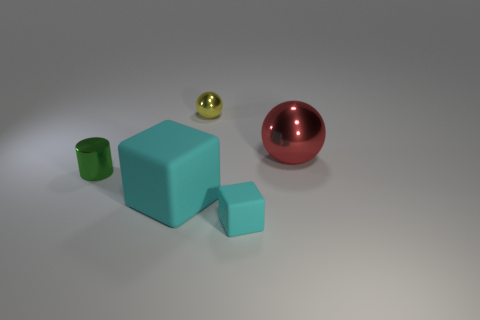How many cyan blocks must be subtracted to get 1 cyan blocks? 1 Add 4 tiny cyan things. How many objects exist? 9 Subtract all cubes. How many objects are left? 3 Add 4 large cyan matte blocks. How many large cyan matte blocks are left? 5 Add 4 cyan matte blocks. How many cyan matte blocks exist? 6 Subtract 0 cyan cylinders. How many objects are left? 5 Subtract all large things. Subtract all metallic things. How many objects are left? 0 